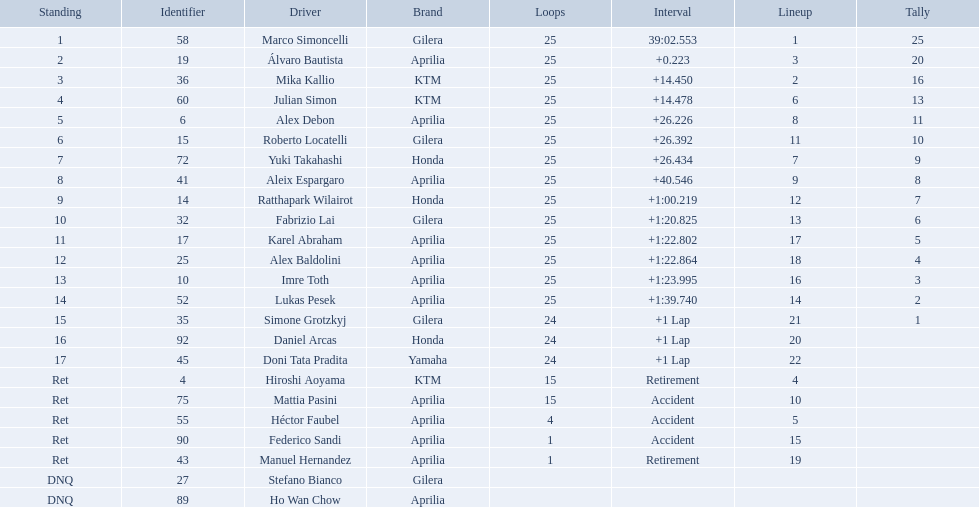How many laps did marco perform? 25. How many laps did hiroshi perform? 15. Which of these numbers are higher? 25. Who swam this number of laps? Marco Simoncelli. How many laps did hiroshi aoyama perform? 15. How many laps did marco simoncelli perform? 25. Who performed more laps out of hiroshi aoyama and marco 
simoncelli? Marco Simoncelli. Who were all of the riders? Marco Simoncelli, Álvaro Bautista, Mika Kallio, Julian Simon, Alex Debon, Roberto Locatelli, Yuki Takahashi, Aleix Espargaro, Ratthapark Wilairot, Fabrizio Lai, Karel Abraham, Alex Baldolini, Imre Toth, Lukas Pesek, Simone Grotzkyj, Daniel Arcas, Doni Tata Pradita, Hiroshi Aoyama, Mattia Pasini, Héctor Faubel, Federico Sandi, Manuel Hernandez, Stefano Bianco, Ho Wan Chow. How many laps did they complete? 25, 25, 25, 25, 25, 25, 25, 25, 25, 25, 25, 25, 25, 25, 24, 24, 24, 15, 15, 4, 1, 1, , . Between marco simoncelli and hiroshi aoyama, who had more laps? Marco Simoncelli. What was the fastest overall time? 39:02.553. Could you help me parse every detail presented in this table? {'header': ['Standing', 'Identifier', 'Driver', 'Brand', 'Loops', 'Interval', 'Lineup', 'Tally'], 'rows': [['1', '58', 'Marco Simoncelli', 'Gilera', '25', '39:02.553', '1', '25'], ['2', '19', 'Álvaro Bautista', 'Aprilia', '25', '+0.223', '3', '20'], ['3', '36', 'Mika Kallio', 'KTM', '25', '+14.450', '2', '16'], ['4', '60', 'Julian Simon', 'KTM', '25', '+14.478', '6', '13'], ['5', '6', 'Alex Debon', 'Aprilia', '25', '+26.226', '8', '11'], ['6', '15', 'Roberto Locatelli', 'Gilera', '25', '+26.392', '11', '10'], ['7', '72', 'Yuki Takahashi', 'Honda', '25', '+26.434', '7', '9'], ['8', '41', 'Aleix Espargaro', 'Aprilia', '25', '+40.546', '9', '8'], ['9', '14', 'Ratthapark Wilairot', 'Honda', '25', '+1:00.219', '12', '7'], ['10', '32', 'Fabrizio Lai', 'Gilera', '25', '+1:20.825', '13', '6'], ['11', '17', 'Karel Abraham', 'Aprilia', '25', '+1:22.802', '17', '5'], ['12', '25', 'Alex Baldolini', 'Aprilia', '25', '+1:22.864', '18', '4'], ['13', '10', 'Imre Toth', 'Aprilia', '25', '+1:23.995', '16', '3'], ['14', '52', 'Lukas Pesek', 'Aprilia', '25', '+1:39.740', '14', '2'], ['15', '35', 'Simone Grotzkyj', 'Gilera', '24', '+1 Lap', '21', '1'], ['16', '92', 'Daniel Arcas', 'Honda', '24', '+1 Lap', '20', ''], ['17', '45', 'Doni Tata Pradita', 'Yamaha', '24', '+1 Lap', '22', ''], ['Ret', '4', 'Hiroshi Aoyama', 'KTM', '15', 'Retirement', '4', ''], ['Ret', '75', 'Mattia Pasini', 'Aprilia', '15', 'Accident', '10', ''], ['Ret', '55', 'Héctor Faubel', 'Aprilia', '4', 'Accident', '5', ''], ['Ret', '90', 'Federico Sandi', 'Aprilia', '1', 'Accident', '15', ''], ['Ret', '43', 'Manuel Hernandez', 'Aprilia', '1', 'Retirement', '19', ''], ['DNQ', '27', 'Stefano Bianco', 'Gilera', '', '', '', ''], ['DNQ', '89', 'Ho Wan Chow', 'Aprilia', '', '', '', '']]} Who does this time belong to? Marco Simoncelli. 